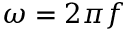<formula> <loc_0><loc_0><loc_500><loc_500>\omega = 2 \pi f</formula> 